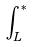Convert formula to latex. <formula><loc_0><loc_0><loc_500><loc_500>\int _ { L } ^ { * }</formula> 